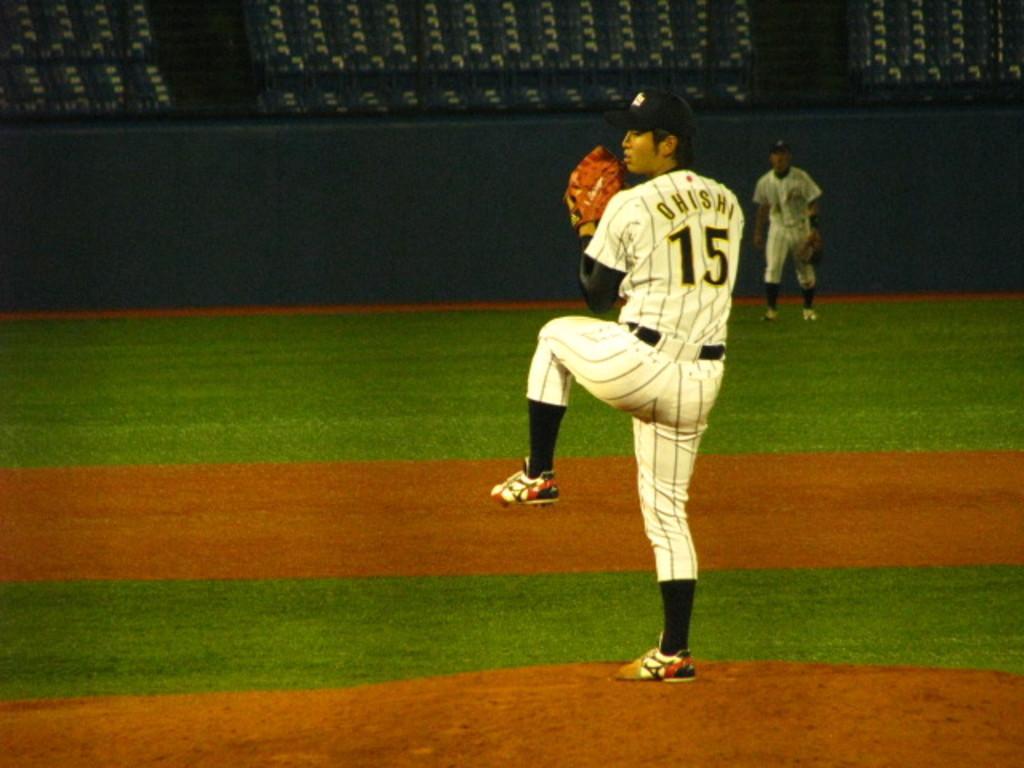Could you give a brief overview of what you see in this image? As we can see in the image there is ground, wall and two people wearing white color dresses. 